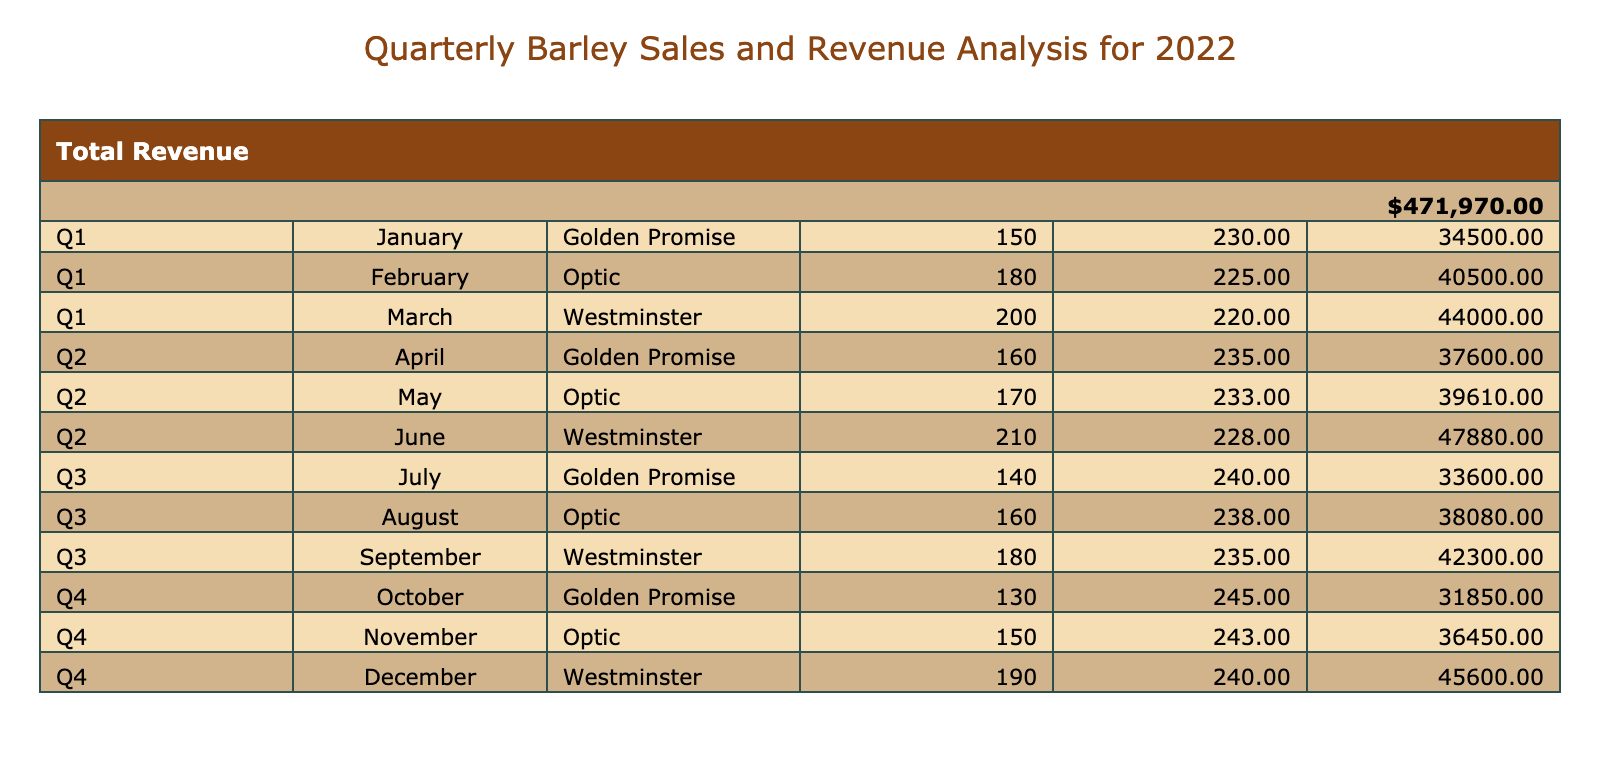What was the total revenue generated from selling the Golden Promise barley variety? To find the total revenue generated from Golden Promise, we look for all rows where the Barley Variety is "Golden Promise." In the table, we have quantities and revenues for January (34,500), April (37,600), July (33,600), and October (31,850). Adding these values, we get 34,500 + 37,600 + 33,600 + 31,850 = 137,550 USD.
Answer: 137,550 USD Which month had the highest price per ton for the Optic barley variety? Checking the table, the months with Optic barley are February, May, and November with prices of 225, 233, and 243 USD respectively. The highest price is 243 USD in November.
Answer: 243 USD in November What was the average quantity of barley sold per month in Q2? For Q2, we look at the quantities sold in April (160), May (170), and June (210). We sum these quantities: 160 + 170 + 210 = 540 tons. Since there are 3 months in Q2, we divide the sum by 3, giving us an average of 540/3 = 180 tons.
Answer: 180 tons Did the revenue for Westminster barley increase from Q1 to Q2? In Q1, the revenue for Westminster is 44,000 USD. In Q2, it’s 47,880 USD. Since 47,880 is greater than 44,000, it indicates that the revenue for Westminster did indeed increase from Q1 to Q2.
Answer: Yes Which barley variety generated the least revenue in Q3? For Q3, we examine the revenues for the different barley varieties: Golden Promise (33,600), Optic (38,080), and Westminster (42,300). The least revenue is for Golden Promise at 33,600 USD.
Answer: Golden Promise at 33,600 USD What is the total revenue generated from selling the Optic variety across the entire year? We need to sum up the revenues for Optic from February (40,500), May (39,610), and November (36,450). Adding these values gives 40,500 + 39,610 + 36,450 = 116,560 USD.
Answer: 116,560 USD How much more revenue was generated from Westminster in Q4 compared to Q1? In Q1, the revenue from Westminster is 44,000 USD, and in Q4, it is 45,600 USD. To find the difference, we subtract the revenue in Q1 from Q4: 45,600 - 44,000 = 1,600 USD.
Answer: 1,600 USD What was the total quantity of barley sold in Q3? Reviewing Q3, we sum the quantities: Golden Promise (140), Optic (160), and Westminster (180). The total quantity is 140 + 160 + 180 = 480 tons.
Answer: 480 tons 